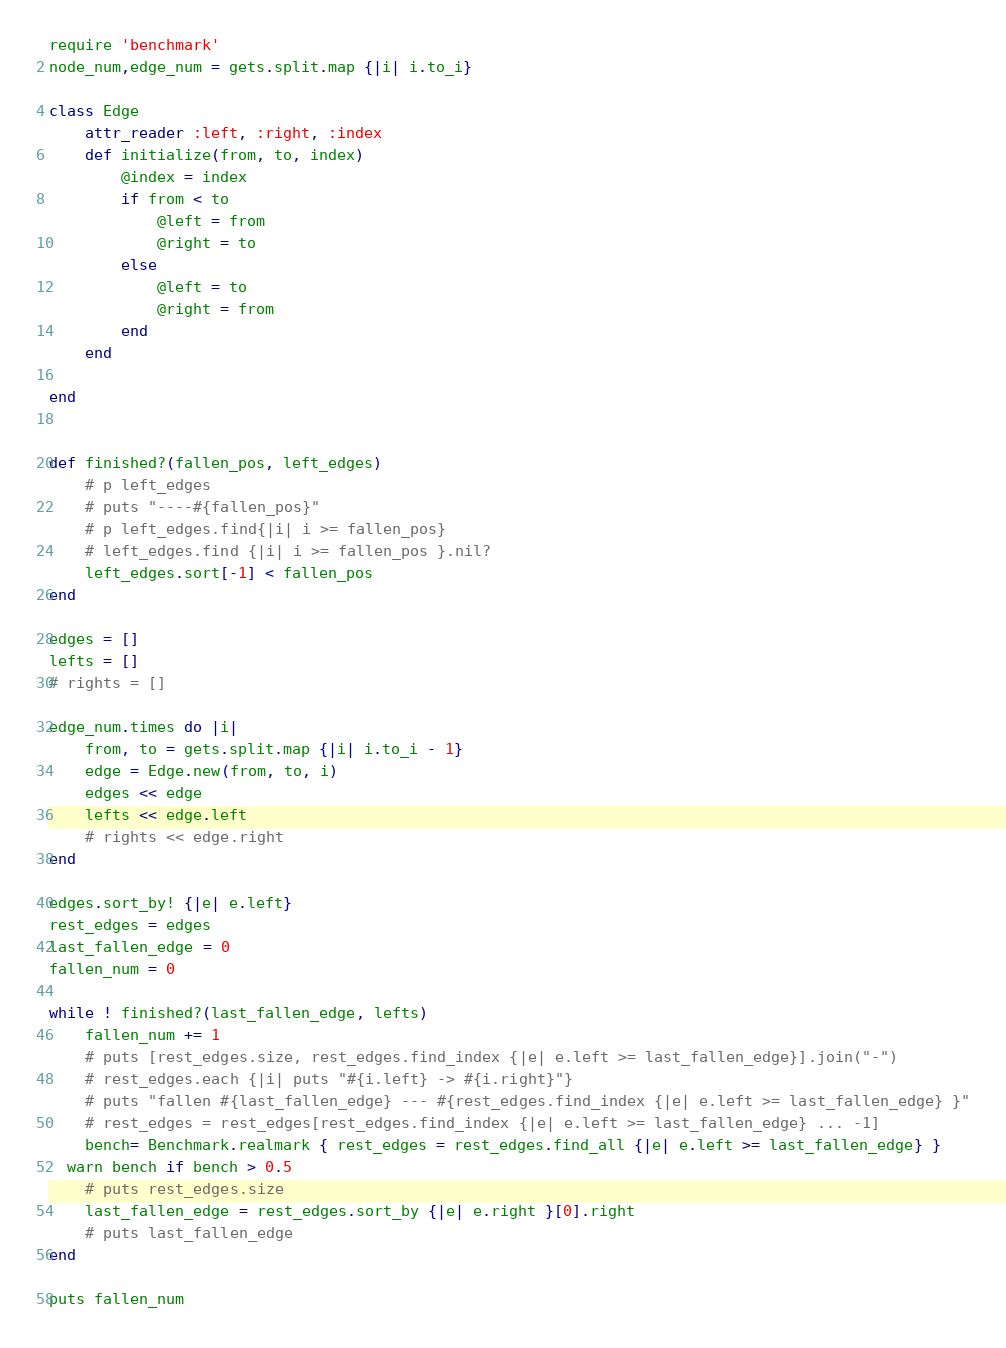Convert code to text. <code><loc_0><loc_0><loc_500><loc_500><_Ruby_>require 'benchmark'
node_num,edge_num = gets.split.map {|i| i.to_i}
 
class Edge
    attr_reader :left, :right, :index
    def initialize(from, to, index)
        @index = index
        if from < to
            @left = from
            @right = to
        else
            @left = to
            @right = from
        end
    end
 
end
 
 
def finished?(fallen_pos, left_edges)
    # p left_edges
    # puts "----#{fallen_pos}"
    # p left_edges.find{|i| i >= fallen_pos}
    # left_edges.find {|i| i >= fallen_pos }.nil?
    left_edges.sort[-1] < fallen_pos
end
 
edges = []
lefts = []
# rights = []
 
edge_num.times do |i|
    from, to = gets.split.map {|i| i.to_i - 1}
    edge = Edge.new(from, to, i)
    edges << edge
    lefts << edge.left
    # rights << edge.right
end
 
edges.sort_by! {|e| e.left}
rest_edges = edges
last_fallen_edge = 0
fallen_num = 0
 
while ! finished?(last_fallen_edge, lefts)
    fallen_num += 1
    # puts [rest_edges.size, rest_edges.find_index {|e| e.left >= last_fallen_edge}].join("-")
    # rest_edges.each {|i| puts "#{i.left} -> #{i.right}"}    
    # puts "fallen #{last_fallen_edge} --- #{rest_edges.find_index {|e| e.left >= last_fallen_edge} }"
    # rest_edges = rest_edges[rest_edges.find_index {|e| e.left >= last_fallen_edge} ... -1]
    bench= Benchmark.realmark { rest_edges = rest_edges.find_all {|e| e.left >= last_fallen_edge} }
  warn bench if bench > 0.5
    # puts rest_edges.size
    last_fallen_edge = rest_edges.sort_by {|e| e.right }[0].right
    # puts last_fallen_edge
end
 
puts fallen_num</code> 